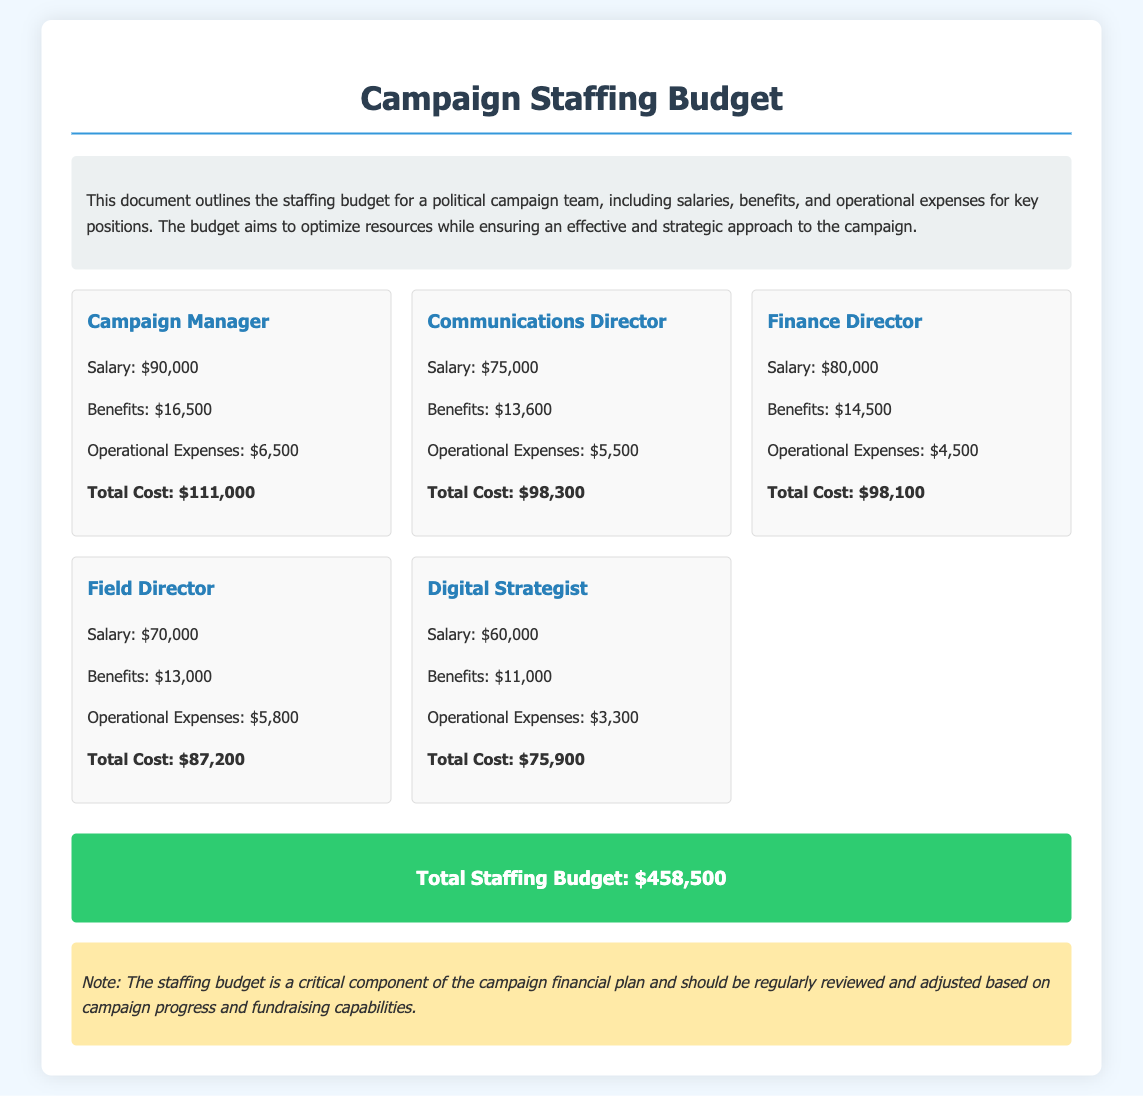What is the salary for the Campaign Manager? The salary for the Campaign Manager is specifically stated in the document.
Answer: $90,000 What are the operational expenses for the Digital Strategist? The document details the operational expenses for each position.
Answer: $3,300 What is the total cost for the Communications Director? The total cost is the sum of salary, benefits, and operational expenses for the Communications Director.
Answer: $98,300 Which position has the highest total cost? The document lists total costs for each position, allowing for comparison to identify the highest.
Answer: Campaign Manager What is the total staffing budget? The total staffing budget is summarized at the end of the document, providing the overall amount allocated for staffing.
Answer: $458,500 What is the benefits amount for the Finance Director? The document provides specific benefits amounts for each position, including the Finance Director.
Answer: $14,500 Which position has the lowest salary? By reviewing the salaries listed for each position, we can identify the lowest salary.
Answer: Digital Strategist Are there any notes in the document? The document includes a specific section for notes, which provides additional context about the staffing budget.
Answer: Yes How many key positions are detailed in the budget? The document lists several positions specifically, allowing for a count of the total number of key positions.
Answer: 5 